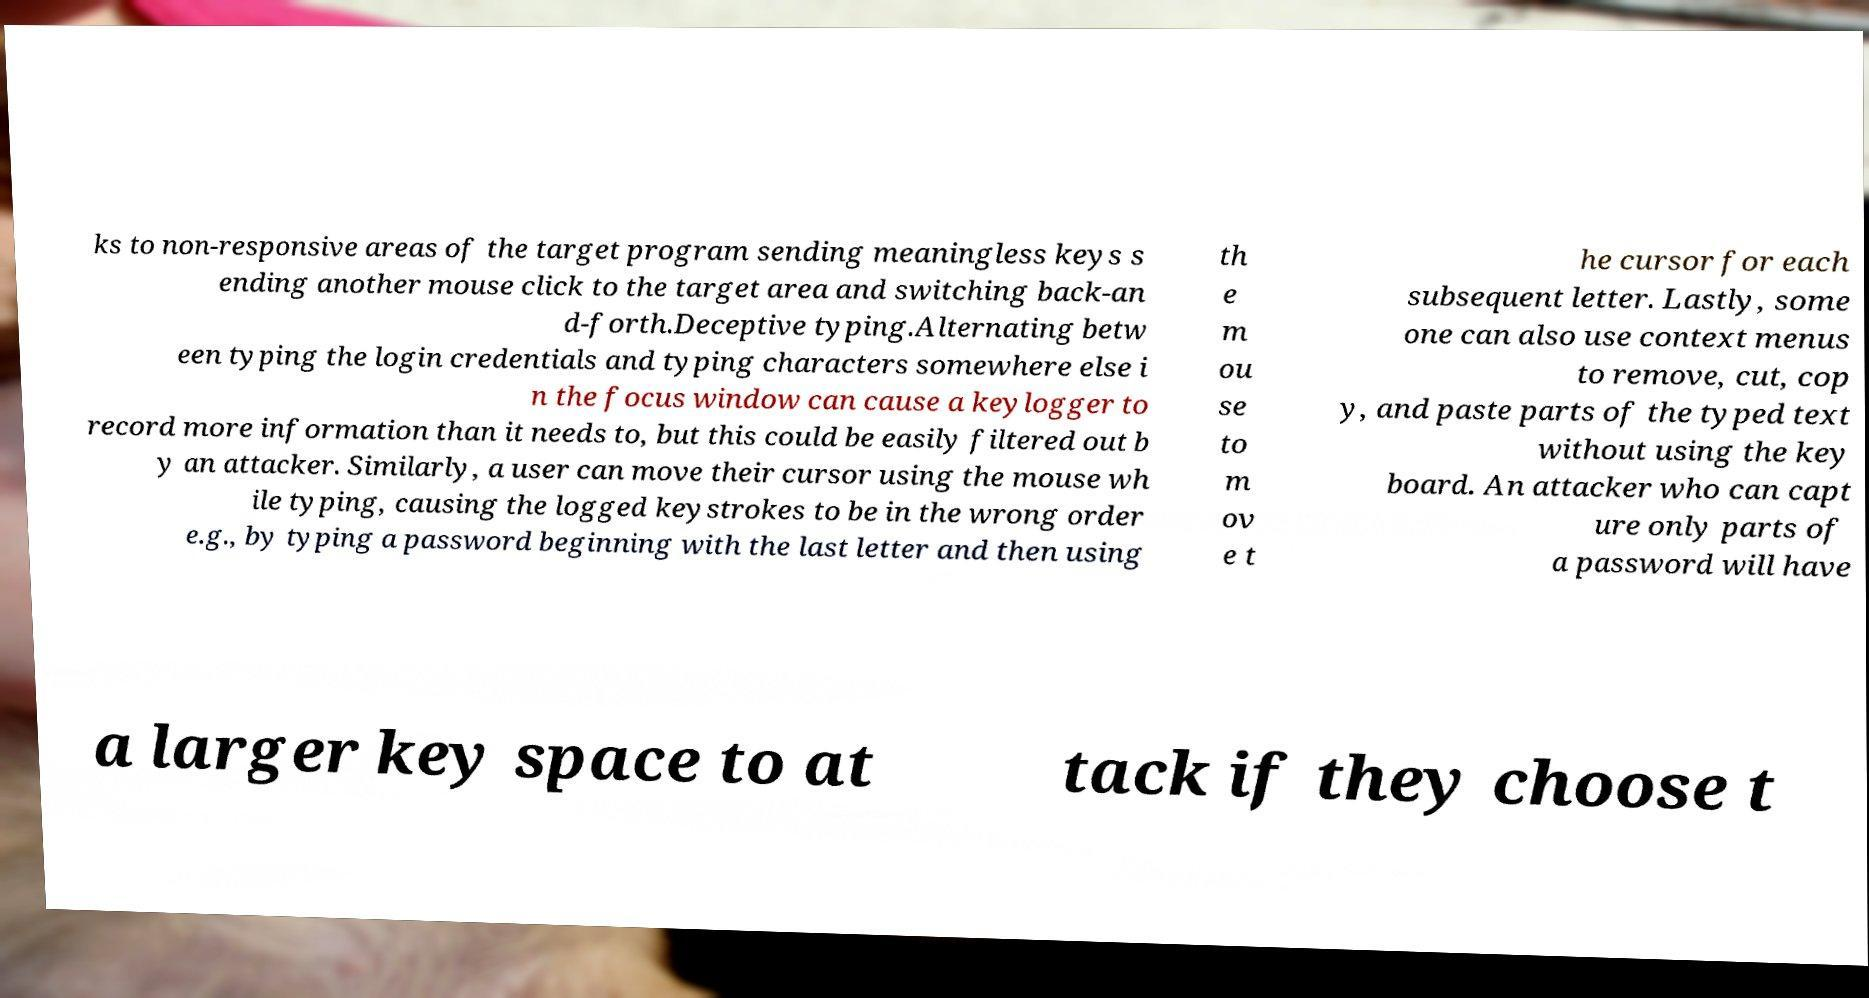Can you read and provide the text displayed in the image?This photo seems to have some interesting text. Can you extract and type it out for me? ks to non-responsive areas of the target program sending meaningless keys s ending another mouse click to the target area and switching back-an d-forth.Deceptive typing.Alternating betw een typing the login credentials and typing characters somewhere else i n the focus window can cause a keylogger to record more information than it needs to, but this could be easily filtered out b y an attacker. Similarly, a user can move their cursor using the mouse wh ile typing, causing the logged keystrokes to be in the wrong order e.g., by typing a password beginning with the last letter and then using th e m ou se to m ov e t he cursor for each subsequent letter. Lastly, some one can also use context menus to remove, cut, cop y, and paste parts of the typed text without using the key board. An attacker who can capt ure only parts of a password will have a larger key space to at tack if they choose t 